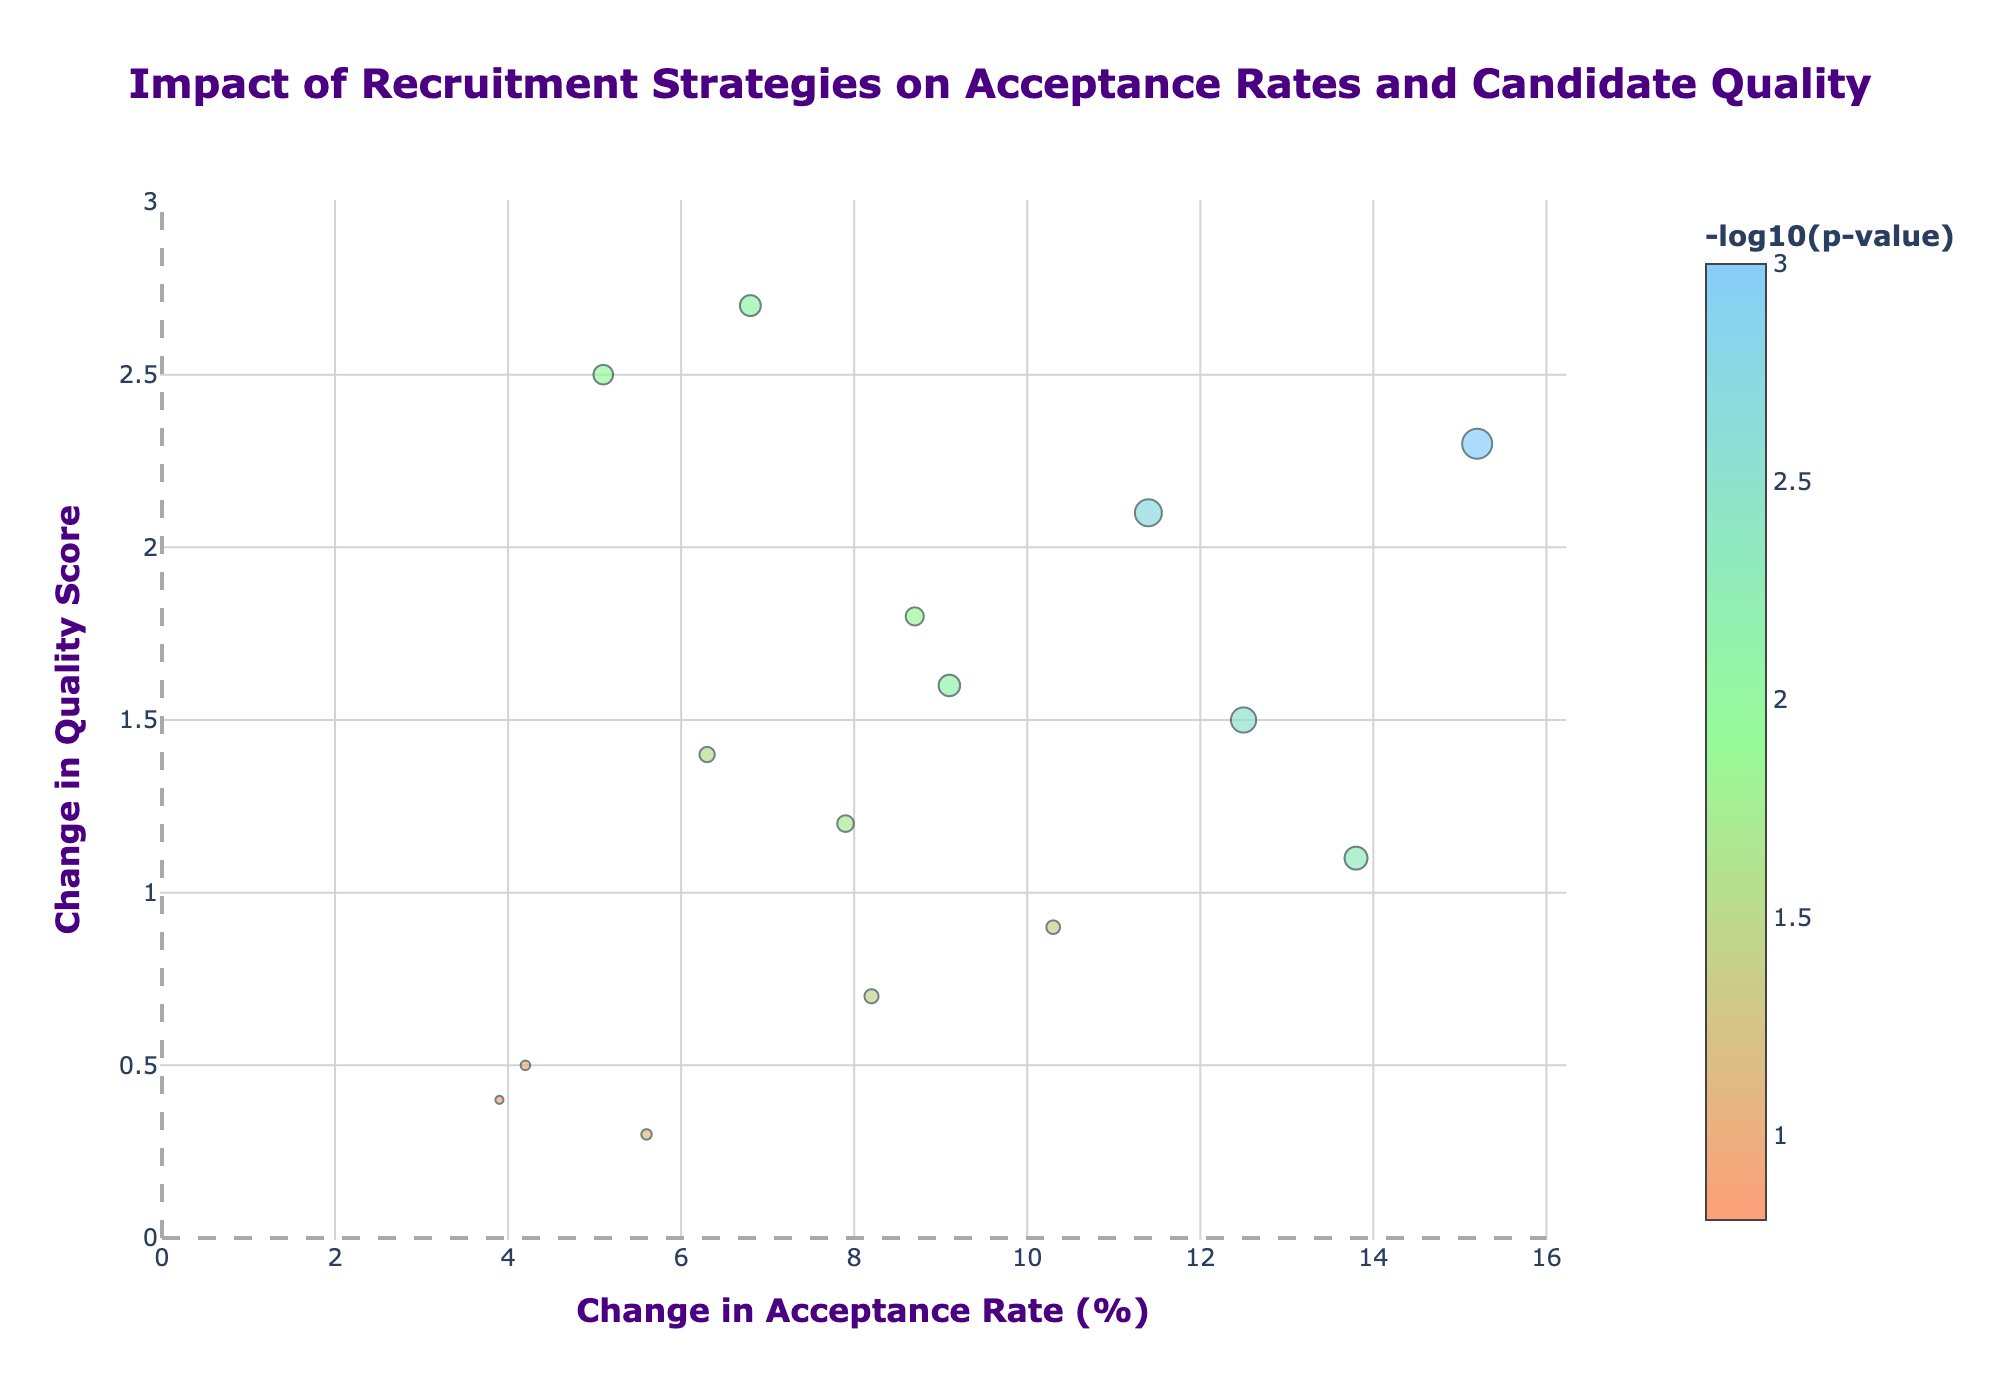What is the title of the plot? The title is written at the top center of the plot. It reads: "Impact of Recruitment Strategies on Acceptance Rates and Candidate Quality".
Answer: Impact of Recruitment Strategies on Acceptance Rates and Candidate Quality Which recruitment strategy shows the highest increase in acceptance rate? Looking at the x-axis, the strategy with the highest x-value represents the Employee Referral Program with a 15.2% increase.
Answer: Employee Referral Program How is the significance of the strategies represented visually? The significance is represented by the size and color of the markers. Larger and more color-intense markers indicate higher significance (-log10(p-value)).
Answer: Marker size and color What is the change in quality score for the strategy with the highest acceptance rate increase? The marker at 15.2% acceptance rate change corresponds to the Employee Referral Program. Its y-value indicates a 2.3 change in quality score.
Answer: 2.3 Which strategies have the most significant impact, indicated by larger marker sizes? Larger marker sizes correspond to smaller p-values. Observing the plot, the Employee Referral Program, Competitive Salary Packages, Professional Development Opportunities, and Signing Bonuses have larger marker sizes.
Answer: Employee Referral Program, Competitive Salary Packages, Professional Development Opportunities, Signing Bonuses Compare the acceptance rate change and quality score change for the AI-Powered Candidate Matching and Hackathon Recruitment Events. Which is better on both axes? AI-Powered Candidate Matching has an acceptance rate change of 8.7% and quality score change of 1.8. Hackathon Recruitment Events have 6.8% and 2.7, respectively. For overall balance, AI-Powered Candidate Matching has higher acceptance rate increase, but Hackathon Recruitment Events have a higher quality score change.
Answer: Varies; AI-Powered Candidate Matching for acceptance rate, Hackathon Recruitment Events for quality score What recruitment strategy has the lowest significance, and how is it represented visually? The LinkedIn Premium Recruiter strategy appears as a smaller and less vibrant marker, indicating its p-value is higher and significance is lower.
Answer: LinkedIn Premium Recruiter Which strategy shows both significant and balanced improvements in acceptance rate and quality score? Diversity and Inclusion Initiatives show an acceptance change of 9.1% and a quality score change of 1.6, coupled with significant marker size and color indicating low p-value.
Answer: Diversity and Inclusion Initiatives How is the x-axis labeled, and what does it represent? The x-axis label printed below the axis reads: "Change in Acceptance Rate (%)". It represents the percentage change in acceptance rate due to different recruitment strategies.
Answer: Change in Acceptance Rate (%) How does the Employee Testimonial Videos strategy compare in significance and results to the Flexible Work Hours strategy? The Employee Testimonial Videos strategy is represented by a smaller, less vibrant marker indicating less significance and shows an acceptance rate change of 3.9% and quality score change of 0.4. Flexible Work Hours show better results with an 8.2% acceptance rate change and 0.7 in quality score, with greater significance.
Answer: Flexible Work Hours is better in both significance and results 